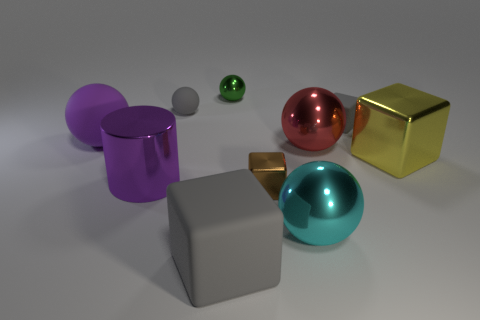Are there any brown cubes of the same size as the yellow metal block?
Keep it short and to the point. No. Are there an equal number of tiny green things to the right of the small brown shiny object and gray blocks?
Your answer should be compact. No. What is the size of the cyan sphere?
Your response must be concise. Large. There is a small brown metallic object on the right side of the large cylinder; what number of large yellow shiny blocks are left of it?
Keep it short and to the point. 0. The object that is both in front of the brown object and on the left side of the tiny brown metal block has what shape?
Provide a succinct answer. Cube. How many tiny rubber things have the same color as the tiny matte cube?
Provide a succinct answer. 1. There is a tiny gray matte object on the left side of the block that is on the left side of the green metal object; are there any red metal things behind it?
Keep it short and to the point. No. There is a block that is right of the tiny brown thing and in front of the purple matte sphere; how big is it?
Provide a succinct answer. Large. How many purple cylinders are made of the same material as the brown block?
Give a very brief answer. 1. What number of spheres are either brown metal things or red metal things?
Offer a very short reply. 1. 